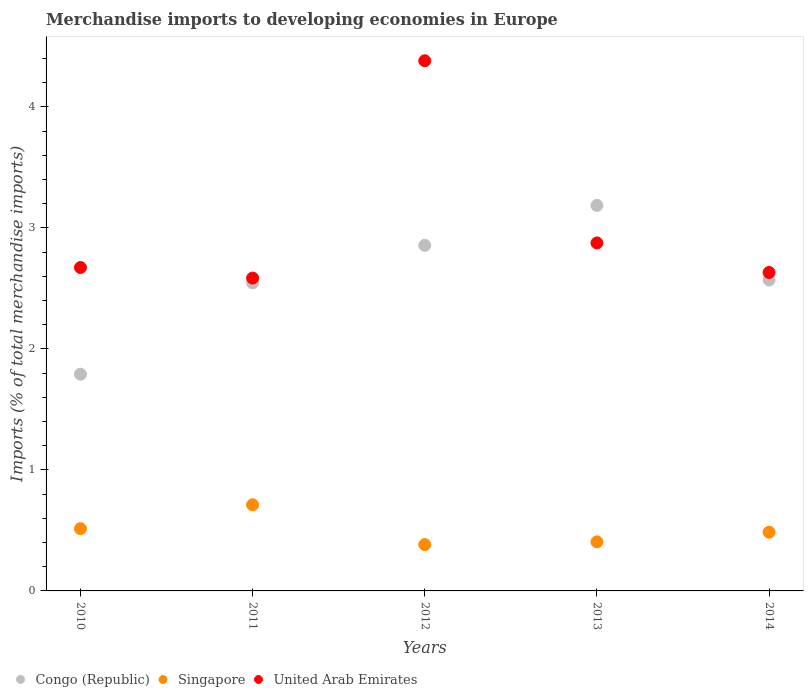How many different coloured dotlines are there?
Offer a very short reply. 3. Is the number of dotlines equal to the number of legend labels?
Keep it short and to the point. Yes. What is the percentage total merchandise imports in United Arab Emirates in 2014?
Your answer should be very brief. 2.63. Across all years, what is the maximum percentage total merchandise imports in United Arab Emirates?
Keep it short and to the point. 4.38. Across all years, what is the minimum percentage total merchandise imports in United Arab Emirates?
Your response must be concise. 2.59. What is the total percentage total merchandise imports in United Arab Emirates in the graph?
Make the answer very short. 15.15. What is the difference between the percentage total merchandise imports in United Arab Emirates in 2013 and that in 2014?
Give a very brief answer. 0.24. What is the difference between the percentage total merchandise imports in Congo (Republic) in 2013 and the percentage total merchandise imports in Singapore in 2012?
Offer a terse response. 2.8. What is the average percentage total merchandise imports in Singapore per year?
Make the answer very short. 0.5. In the year 2012, what is the difference between the percentage total merchandise imports in United Arab Emirates and percentage total merchandise imports in Singapore?
Offer a terse response. 4. What is the ratio of the percentage total merchandise imports in Congo (Republic) in 2012 to that in 2014?
Offer a terse response. 1.11. Is the percentage total merchandise imports in United Arab Emirates in 2010 less than that in 2013?
Keep it short and to the point. Yes. What is the difference between the highest and the second highest percentage total merchandise imports in United Arab Emirates?
Your answer should be very brief. 1.51. What is the difference between the highest and the lowest percentage total merchandise imports in United Arab Emirates?
Provide a short and direct response. 1.8. Does the percentage total merchandise imports in Congo (Republic) monotonically increase over the years?
Ensure brevity in your answer.  No. How many years are there in the graph?
Give a very brief answer. 5. Does the graph contain any zero values?
Provide a short and direct response. No. Where does the legend appear in the graph?
Your answer should be compact. Bottom left. How many legend labels are there?
Your response must be concise. 3. How are the legend labels stacked?
Provide a short and direct response. Horizontal. What is the title of the graph?
Your response must be concise. Merchandise imports to developing economies in Europe. Does "Middle East & North Africa (developing only)" appear as one of the legend labels in the graph?
Keep it short and to the point. No. What is the label or title of the X-axis?
Your response must be concise. Years. What is the label or title of the Y-axis?
Your answer should be very brief. Imports (% of total merchandise imports). What is the Imports (% of total merchandise imports) in Congo (Republic) in 2010?
Make the answer very short. 1.79. What is the Imports (% of total merchandise imports) of Singapore in 2010?
Give a very brief answer. 0.51. What is the Imports (% of total merchandise imports) in United Arab Emirates in 2010?
Offer a terse response. 2.67. What is the Imports (% of total merchandise imports) in Congo (Republic) in 2011?
Provide a succinct answer. 2.55. What is the Imports (% of total merchandise imports) of Singapore in 2011?
Your response must be concise. 0.71. What is the Imports (% of total merchandise imports) of United Arab Emirates in 2011?
Your answer should be compact. 2.59. What is the Imports (% of total merchandise imports) in Congo (Republic) in 2012?
Your answer should be compact. 2.86. What is the Imports (% of total merchandise imports) in Singapore in 2012?
Offer a terse response. 0.38. What is the Imports (% of total merchandise imports) in United Arab Emirates in 2012?
Keep it short and to the point. 4.38. What is the Imports (% of total merchandise imports) of Congo (Republic) in 2013?
Ensure brevity in your answer.  3.19. What is the Imports (% of total merchandise imports) in Singapore in 2013?
Keep it short and to the point. 0.41. What is the Imports (% of total merchandise imports) in United Arab Emirates in 2013?
Make the answer very short. 2.88. What is the Imports (% of total merchandise imports) of Congo (Republic) in 2014?
Your answer should be very brief. 2.57. What is the Imports (% of total merchandise imports) in Singapore in 2014?
Offer a terse response. 0.49. What is the Imports (% of total merchandise imports) in United Arab Emirates in 2014?
Make the answer very short. 2.63. Across all years, what is the maximum Imports (% of total merchandise imports) of Congo (Republic)?
Provide a succinct answer. 3.19. Across all years, what is the maximum Imports (% of total merchandise imports) of Singapore?
Provide a short and direct response. 0.71. Across all years, what is the maximum Imports (% of total merchandise imports) of United Arab Emirates?
Keep it short and to the point. 4.38. Across all years, what is the minimum Imports (% of total merchandise imports) of Congo (Republic)?
Make the answer very short. 1.79. Across all years, what is the minimum Imports (% of total merchandise imports) of Singapore?
Ensure brevity in your answer.  0.38. Across all years, what is the minimum Imports (% of total merchandise imports) of United Arab Emirates?
Give a very brief answer. 2.59. What is the total Imports (% of total merchandise imports) in Congo (Republic) in the graph?
Offer a terse response. 12.95. What is the total Imports (% of total merchandise imports) in Singapore in the graph?
Keep it short and to the point. 2.5. What is the total Imports (% of total merchandise imports) of United Arab Emirates in the graph?
Provide a succinct answer. 15.15. What is the difference between the Imports (% of total merchandise imports) in Congo (Republic) in 2010 and that in 2011?
Keep it short and to the point. -0.76. What is the difference between the Imports (% of total merchandise imports) in Singapore in 2010 and that in 2011?
Your response must be concise. -0.2. What is the difference between the Imports (% of total merchandise imports) in United Arab Emirates in 2010 and that in 2011?
Offer a terse response. 0.09. What is the difference between the Imports (% of total merchandise imports) in Congo (Republic) in 2010 and that in 2012?
Provide a succinct answer. -1.06. What is the difference between the Imports (% of total merchandise imports) in Singapore in 2010 and that in 2012?
Provide a short and direct response. 0.13. What is the difference between the Imports (% of total merchandise imports) in United Arab Emirates in 2010 and that in 2012?
Your answer should be compact. -1.71. What is the difference between the Imports (% of total merchandise imports) in Congo (Republic) in 2010 and that in 2013?
Make the answer very short. -1.39. What is the difference between the Imports (% of total merchandise imports) in Singapore in 2010 and that in 2013?
Your answer should be very brief. 0.11. What is the difference between the Imports (% of total merchandise imports) of United Arab Emirates in 2010 and that in 2013?
Keep it short and to the point. -0.2. What is the difference between the Imports (% of total merchandise imports) in Congo (Republic) in 2010 and that in 2014?
Your answer should be very brief. -0.78. What is the difference between the Imports (% of total merchandise imports) in Singapore in 2010 and that in 2014?
Provide a short and direct response. 0.03. What is the difference between the Imports (% of total merchandise imports) of United Arab Emirates in 2010 and that in 2014?
Keep it short and to the point. 0.04. What is the difference between the Imports (% of total merchandise imports) in Congo (Republic) in 2011 and that in 2012?
Your answer should be very brief. -0.31. What is the difference between the Imports (% of total merchandise imports) of Singapore in 2011 and that in 2012?
Keep it short and to the point. 0.33. What is the difference between the Imports (% of total merchandise imports) of United Arab Emirates in 2011 and that in 2012?
Your response must be concise. -1.8. What is the difference between the Imports (% of total merchandise imports) in Congo (Republic) in 2011 and that in 2013?
Keep it short and to the point. -0.64. What is the difference between the Imports (% of total merchandise imports) in Singapore in 2011 and that in 2013?
Provide a succinct answer. 0.31. What is the difference between the Imports (% of total merchandise imports) in United Arab Emirates in 2011 and that in 2013?
Ensure brevity in your answer.  -0.29. What is the difference between the Imports (% of total merchandise imports) of Congo (Republic) in 2011 and that in 2014?
Make the answer very short. -0.02. What is the difference between the Imports (% of total merchandise imports) in Singapore in 2011 and that in 2014?
Ensure brevity in your answer.  0.23. What is the difference between the Imports (% of total merchandise imports) of United Arab Emirates in 2011 and that in 2014?
Offer a very short reply. -0.05. What is the difference between the Imports (% of total merchandise imports) of Congo (Republic) in 2012 and that in 2013?
Ensure brevity in your answer.  -0.33. What is the difference between the Imports (% of total merchandise imports) of Singapore in 2012 and that in 2013?
Provide a succinct answer. -0.02. What is the difference between the Imports (% of total merchandise imports) of United Arab Emirates in 2012 and that in 2013?
Ensure brevity in your answer.  1.51. What is the difference between the Imports (% of total merchandise imports) in Congo (Republic) in 2012 and that in 2014?
Keep it short and to the point. 0.29. What is the difference between the Imports (% of total merchandise imports) in Singapore in 2012 and that in 2014?
Your answer should be very brief. -0.1. What is the difference between the Imports (% of total merchandise imports) in United Arab Emirates in 2012 and that in 2014?
Offer a terse response. 1.75. What is the difference between the Imports (% of total merchandise imports) of Congo (Republic) in 2013 and that in 2014?
Provide a succinct answer. 0.62. What is the difference between the Imports (% of total merchandise imports) in Singapore in 2013 and that in 2014?
Give a very brief answer. -0.08. What is the difference between the Imports (% of total merchandise imports) of United Arab Emirates in 2013 and that in 2014?
Your response must be concise. 0.24. What is the difference between the Imports (% of total merchandise imports) in Congo (Republic) in 2010 and the Imports (% of total merchandise imports) in Singapore in 2011?
Make the answer very short. 1.08. What is the difference between the Imports (% of total merchandise imports) of Congo (Republic) in 2010 and the Imports (% of total merchandise imports) of United Arab Emirates in 2011?
Make the answer very short. -0.79. What is the difference between the Imports (% of total merchandise imports) of Singapore in 2010 and the Imports (% of total merchandise imports) of United Arab Emirates in 2011?
Your response must be concise. -2.07. What is the difference between the Imports (% of total merchandise imports) in Congo (Republic) in 2010 and the Imports (% of total merchandise imports) in Singapore in 2012?
Give a very brief answer. 1.41. What is the difference between the Imports (% of total merchandise imports) in Congo (Republic) in 2010 and the Imports (% of total merchandise imports) in United Arab Emirates in 2012?
Keep it short and to the point. -2.59. What is the difference between the Imports (% of total merchandise imports) in Singapore in 2010 and the Imports (% of total merchandise imports) in United Arab Emirates in 2012?
Provide a succinct answer. -3.87. What is the difference between the Imports (% of total merchandise imports) in Congo (Republic) in 2010 and the Imports (% of total merchandise imports) in Singapore in 2013?
Offer a terse response. 1.39. What is the difference between the Imports (% of total merchandise imports) in Congo (Republic) in 2010 and the Imports (% of total merchandise imports) in United Arab Emirates in 2013?
Your answer should be very brief. -1.08. What is the difference between the Imports (% of total merchandise imports) of Singapore in 2010 and the Imports (% of total merchandise imports) of United Arab Emirates in 2013?
Provide a short and direct response. -2.36. What is the difference between the Imports (% of total merchandise imports) of Congo (Republic) in 2010 and the Imports (% of total merchandise imports) of Singapore in 2014?
Make the answer very short. 1.31. What is the difference between the Imports (% of total merchandise imports) in Congo (Republic) in 2010 and the Imports (% of total merchandise imports) in United Arab Emirates in 2014?
Provide a short and direct response. -0.84. What is the difference between the Imports (% of total merchandise imports) in Singapore in 2010 and the Imports (% of total merchandise imports) in United Arab Emirates in 2014?
Offer a terse response. -2.12. What is the difference between the Imports (% of total merchandise imports) of Congo (Republic) in 2011 and the Imports (% of total merchandise imports) of Singapore in 2012?
Your response must be concise. 2.16. What is the difference between the Imports (% of total merchandise imports) in Congo (Republic) in 2011 and the Imports (% of total merchandise imports) in United Arab Emirates in 2012?
Offer a terse response. -1.84. What is the difference between the Imports (% of total merchandise imports) in Singapore in 2011 and the Imports (% of total merchandise imports) in United Arab Emirates in 2012?
Your answer should be very brief. -3.67. What is the difference between the Imports (% of total merchandise imports) in Congo (Republic) in 2011 and the Imports (% of total merchandise imports) in Singapore in 2013?
Your response must be concise. 2.14. What is the difference between the Imports (% of total merchandise imports) in Congo (Republic) in 2011 and the Imports (% of total merchandise imports) in United Arab Emirates in 2013?
Provide a short and direct response. -0.33. What is the difference between the Imports (% of total merchandise imports) in Singapore in 2011 and the Imports (% of total merchandise imports) in United Arab Emirates in 2013?
Offer a very short reply. -2.16. What is the difference between the Imports (% of total merchandise imports) in Congo (Republic) in 2011 and the Imports (% of total merchandise imports) in Singapore in 2014?
Offer a terse response. 2.06. What is the difference between the Imports (% of total merchandise imports) of Congo (Republic) in 2011 and the Imports (% of total merchandise imports) of United Arab Emirates in 2014?
Provide a succinct answer. -0.09. What is the difference between the Imports (% of total merchandise imports) in Singapore in 2011 and the Imports (% of total merchandise imports) in United Arab Emirates in 2014?
Provide a short and direct response. -1.92. What is the difference between the Imports (% of total merchandise imports) of Congo (Republic) in 2012 and the Imports (% of total merchandise imports) of Singapore in 2013?
Your response must be concise. 2.45. What is the difference between the Imports (% of total merchandise imports) of Congo (Republic) in 2012 and the Imports (% of total merchandise imports) of United Arab Emirates in 2013?
Offer a terse response. -0.02. What is the difference between the Imports (% of total merchandise imports) of Singapore in 2012 and the Imports (% of total merchandise imports) of United Arab Emirates in 2013?
Your answer should be very brief. -2.49. What is the difference between the Imports (% of total merchandise imports) of Congo (Republic) in 2012 and the Imports (% of total merchandise imports) of Singapore in 2014?
Give a very brief answer. 2.37. What is the difference between the Imports (% of total merchandise imports) in Congo (Republic) in 2012 and the Imports (% of total merchandise imports) in United Arab Emirates in 2014?
Offer a very short reply. 0.22. What is the difference between the Imports (% of total merchandise imports) in Singapore in 2012 and the Imports (% of total merchandise imports) in United Arab Emirates in 2014?
Your answer should be compact. -2.25. What is the difference between the Imports (% of total merchandise imports) in Congo (Republic) in 2013 and the Imports (% of total merchandise imports) in Singapore in 2014?
Your answer should be compact. 2.7. What is the difference between the Imports (% of total merchandise imports) of Congo (Republic) in 2013 and the Imports (% of total merchandise imports) of United Arab Emirates in 2014?
Provide a short and direct response. 0.55. What is the difference between the Imports (% of total merchandise imports) in Singapore in 2013 and the Imports (% of total merchandise imports) in United Arab Emirates in 2014?
Provide a short and direct response. -2.23. What is the average Imports (% of total merchandise imports) of Congo (Republic) per year?
Offer a very short reply. 2.59. What is the average Imports (% of total merchandise imports) of Singapore per year?
Offer a terse response. 0.5. What is the average Imports (% of total merchandise imports) in United Arab Emirates per year?
Your response must be concise. 3.03. In the year 2010, what is the difference between the Imports (% of total merchandise imports) of Congo (Republic) and Imports (% of total merchandise imports) of Singapore?
Your answer should be compact. 1.28. In the year 2010, what is the difference between the Imports (% of total merchandise imports) in Congo (Republic) and Imports (% of total merchandise imports) in United Arab Emirates?
Your answer should be compact. -0.88. In the year 2010, what is the difference between the Imports (% of total merchandise imports) of Singapore and Imports (% of total merchandise imports) of United Arab Emirates?
Keep it short and to the point. -2.16. In the year 2011, what is the difference between the Imports (% of total merchandise imports) of Congo (Republic) and Imports (% of total merchandise imports) of Singapore?
Your answer should be very brief. 1.83. In the year 2011, what is the difference between the Imports (% of total merchandise imports) in Congo (Republic) and Imports (% of total merchandise imports) in United Arab Emirates?
Offer a very short reply. -0.04. In the year 2011, what is the difference between the Imports (% of total merchandise imports) of Singapore and Imports (% of total merchandise imports) of United Arab Emirates?
Your answer should be compact. -1.87. In the year 2012, what is the difference between the Imports (% of total merchandise imports) in Congo (Republic) and Imports (% of total merchandise imports) in Singapore?
Provide a succinct answer. 2.47. In the year 2012, what is the difference between the Imports (% of total merchandise imports) in Congo (Republic) and Imports (% of total merchandise imports) in United Arab Emirates?
Make the answer very short. -1.53. In the year 2012, what is the difference between the Imports (% of total merchandise imports) in Singapore and Imports (% of total merchandise imports) in United Arab Emirates?
Your answer should be very brief. -4. In the year 2013, what is the difference between the Imports (% of total merchandise imports) of Congo (Republic) and Imports (% of total merchandise imports) of Singapore?
Ensure brevity in your answer.  2.78. In the year 2013, what is the difference between the Imports (% of total merchandise imports) in Congo (Republic) and Imports (% of total merchandise imports) in United Arab Emirates?
Offer a very short reply. 0.31. In the year 2013, what is the difference between the Imports (% of total merchandise imports) of Singapore and Imports (% of total merchandise imports) of United Arab Emirates?
Your response must be concise. -2.47. In the year 2014, what is the difference between the Imports (% of total merchandise imports) of Congo (Republic) and Imports (% of total merchandise imports) of Singapore?
Provide a short and direct response. 2.08. In the year 2014, what is the difference between the Imports (% of total merchandise imports) in Congo (Republic) and Imports (% of total merchandise imports) in United Arab Emirates?
Ensure brevity in your answer.  -0.06. In the year 2014, what is the difference between the Imports (% of total merchandise imports) in Singapore and Imports (% of total merchandise imports) in United Arab Emirates?
Provide a short and direct response. -2.15. What is the ratio of the Imports (% of total merchandise imports) in Congo (Republic) in 2010 to that in 2011?
Offer a very short reply. 0.7. What is the ratio of the Imports (% of total merchandise imports) of Singapore in 2010 to that in 2011?
Offer a terse response. 0.72. What is the ratio of the Imports (% of total merchandise imports) of United Arab Emirates in 2010 to that in 2011?
Your answer should be compact. 1.03. What is the ratio of the Imports (% of total merchandise imports) in Congo (Republic) in 2010 to that in 2012?
Your answer should be compact. 0.63. What is the ratio of the Imports (% of total merchandise imports) of Singapore in 2010 to that in 2012?
Your answer should be compact. 1.34. What is the ratio of the Imports (% of total merchandise imports) of United Arab Emirates in 2010 to that in 2012?
Ensure brevity in your answer.  0.61. What is the ratio of the Imports (% of total merchandise imports) in Congo (Republic) in 2010 to that in 2013?
Ensure brevity in your answer.  0.56. What is the ratio of the Imports (% of total merchandise imports) of Singapore in 2010 to that in 2013?
Offer a very short reply. 1.27. What is the ratio of the Imports (% of total merchandise imports) in United Arab Emirates in 2010 to that in 2013?
Give a very brief answer. 0.93. What is the ratio of the Imports (% of total merchandise imports) in Congo (Republic) in 2010 to that in 2014?
Make the answer very short. 0.7. What is the ratio of the Imports (% of total merchandise imports) of Singapore in 2010 to that in 2014?
Provide a succinct answer. 1.06. What is the ratio of the Imports (% of total merchandise imports) of United Arab Emirates in 2010 to that in 2014?
Provide a succinct answer. 1.02. What is the ratio of the Imports (% of total merchandise imports) of Congo (Republic) in 2011 to that in 2012?
Offer a very short reply. 0.89. What is the ratio of the Imports (% of total merchandise imports) of Singapore in 2011 to that in 2012?
Make the answer very short. 1.86. What is the ratio of the Imports (% of total merchandise imports) in United Arab Emirates in 2011 to that in 2012?
Give a very brief answer. 0.59. What is the ratio of the Imports (% of total merchandise imports) in Congo (Republic) in 2011 to that in 2013?
Provide a short and direct response. 0.8. What is the ratio of the Imports (% of total merchandise imports) in Singapore in 2011 to that in 2013?
Give a very brief answer. 1.76. What is the ratio of the Imports (% of total merchandise imports) of United Arab Emirates in 2011 to that in 2013?
Your answer should be compact. 0.9. What is the ratio of the Imports (% of total merchandise imports) in Congo (Republic) in 2011 to that in 2014?
Offer a terse response. 0.99. What is the ratio of the Imports (% of total merchandise imports) of Singapore in 2011 to that in 2014?
Give a very brief answer. 1.47. What is the ratio of the Imports (% of total merchandise imports) in United Arab Emirates in 2011 to that in 2014?
Offer a terse response. 0.98. What is the ratio of the Imports (% of total merchandise imports) of Congo (Republic) in 2012 to that in 2013?
Give a very brief answer. 0.9. What is the ratio of the Imports (% of total merchandise imports) of Singapore in 2012 to that in 2013?
Your answer should be compact. 0.94. What is the ratio of the Imports (% of total merchandise imports) in United Arab Emirates in 2012 to that in 2013?
Your answer should be compact. 1.52. What is the ratio of the Imports (% of total merchandise imports) in Congo (Republic) in 2012 to that in 2014?
Give a very brief answer. 1.11. What is the ratio of the Imports (% of total merchandise imports) of Singapore in 2012 to that in 2014?
Your answer should be very brief. 0.79. What is the ratio of the Imports (% of total merchandise imports) of United Arab Emirates in 2012 to that in 2014?
Offer a terse response. 1.66. What is the ratio of the Imports (% of total merchandise imports) in Congo (Republic) in 2013 to that in 2014?
Provide a short and direct response. 1.24. What is the ratio of the Imports (% of total merchandise imports) in Singapore in 2013 to that in 2014?
Provide a short and direct response. 0.84. What is the ratio of the Imports (% of total merchandise imports) of United Arab Emirates in 2013 to that in 2014?
Provide a succinct answer. 1.09. What is the difference between the highest and the second highest Imports (% of total merchandise imports) of Congo (Republic)?
Your response must be concise. 0.33. What is the difference between the highest and the second highest Imports (% of total merchandise imports) of Singapore?
Provide a short and direct response. 0.2. What is the difference between the highest and the second highest Imports (% of total merchandise imports) of United Arab Emirates?
Provide a short and direct response. 1.51. What is the difference between the highest and the lowest Imports (% of total merchandise imports) in Congo (Republic)?
Your answer should be compact. 1.39. What is the difference between the highest and the lowest Imports (% of total merchandise imports) in Singapore?
Your response must be concise. 0.33. What is the difference between the highest and the lowest Imports (% of total merchandise imports) in United Arab Emirates?
Offer a terse response. 1.8. 